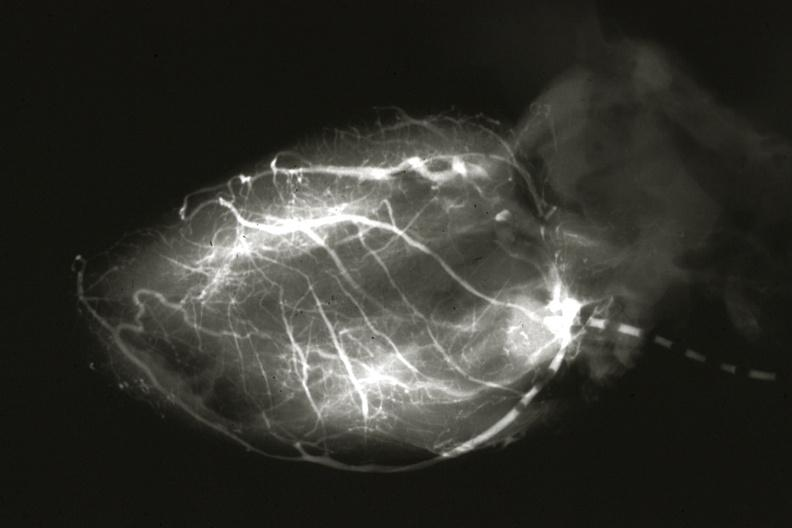what is anomalous origin left?
Answer the question using a single word or phrase. From pulmonary artery 